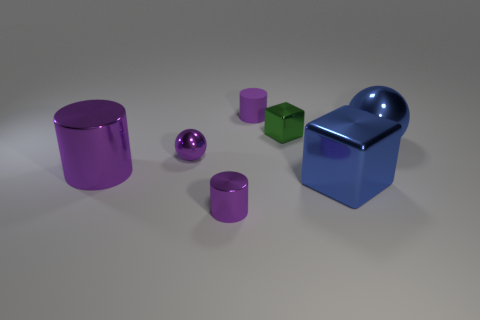How many purple cylinders must be subtracted to get 1 purple cylinders? 2 Subtract all metal cylinders. How many cylinders are left? 1 Subtract all cylinders. How many objects are left? 4 Add 2 large cubes. How many objects exist? 9 Subtract all blue blocks. How many blocks are left? 1 Subtract 2 cylinders. How many cylinders are left? 1 Subtract all blue cylinders. Subtract all brown spheres. How many cylinders are left? 3 Subtract all brown cylinders. How many purple balls are left? 1 Subtract all small purple rubber objects. Subtract all purple metallic things. How many objects are left? 3 Add 3 small purple cylinders. How many small purple cylinders are left? 5 